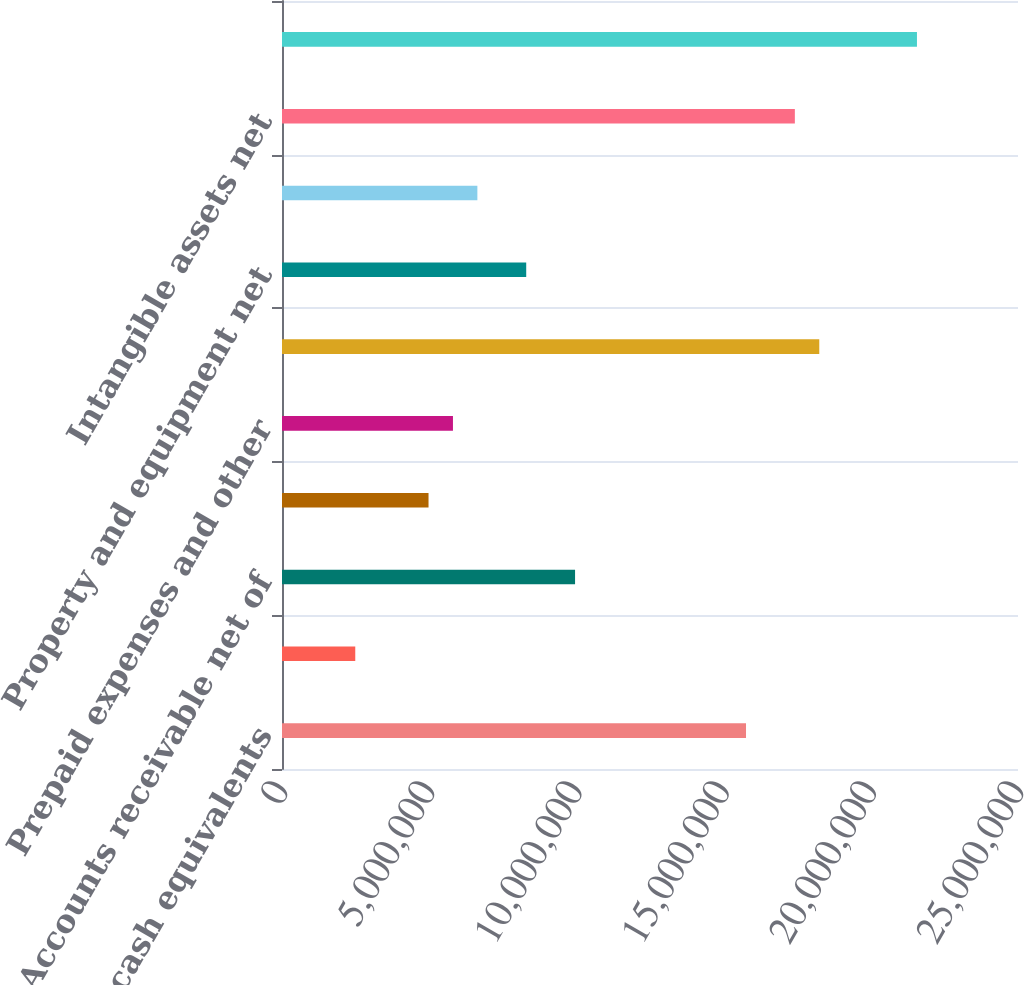Convert chart. <chart><loc_0><loc_0><loc_500><loc_500><bar_chart><fcel>Cash and cash equivalents<fcel>Restricted cash and cash<fcel>Accounts receivable net of<fcel>Prepaid merchant bookings<fcel>Prepaid expenses and other<fcel>Total current assets<fcel>Property and equipment net<fcel>Long-term investments and<fcel>Intangible assets net<fcel>TOTAL ASSETS<nl><fcel>1.57613e+07<fcel>2.48864e+06<fcel>9.9545e+06<fcel>4.97726e+06<fcel>5.8068e+06<fcel>1.82499e+07<fcel>8.29542e+06<fcel>6.63634e+06<fcel>1.74204e+07<fcel>2.15681e+07<nl></chart> 